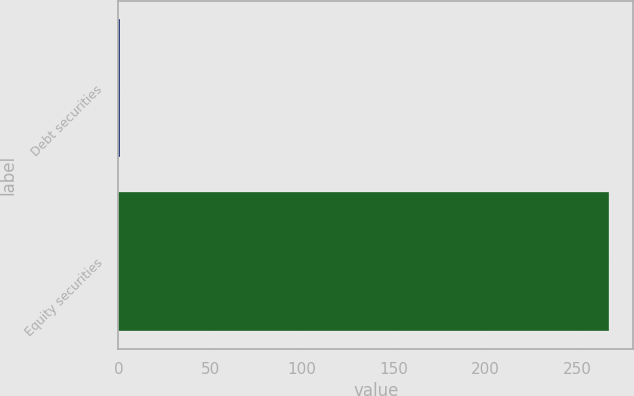<chart> <loc_0><loc_0><loc_500><loc_500><bar_chart><fcel>Debt securities<fcel>Equity securities<nl><fcel>1<fcel>267<nl></chart> 